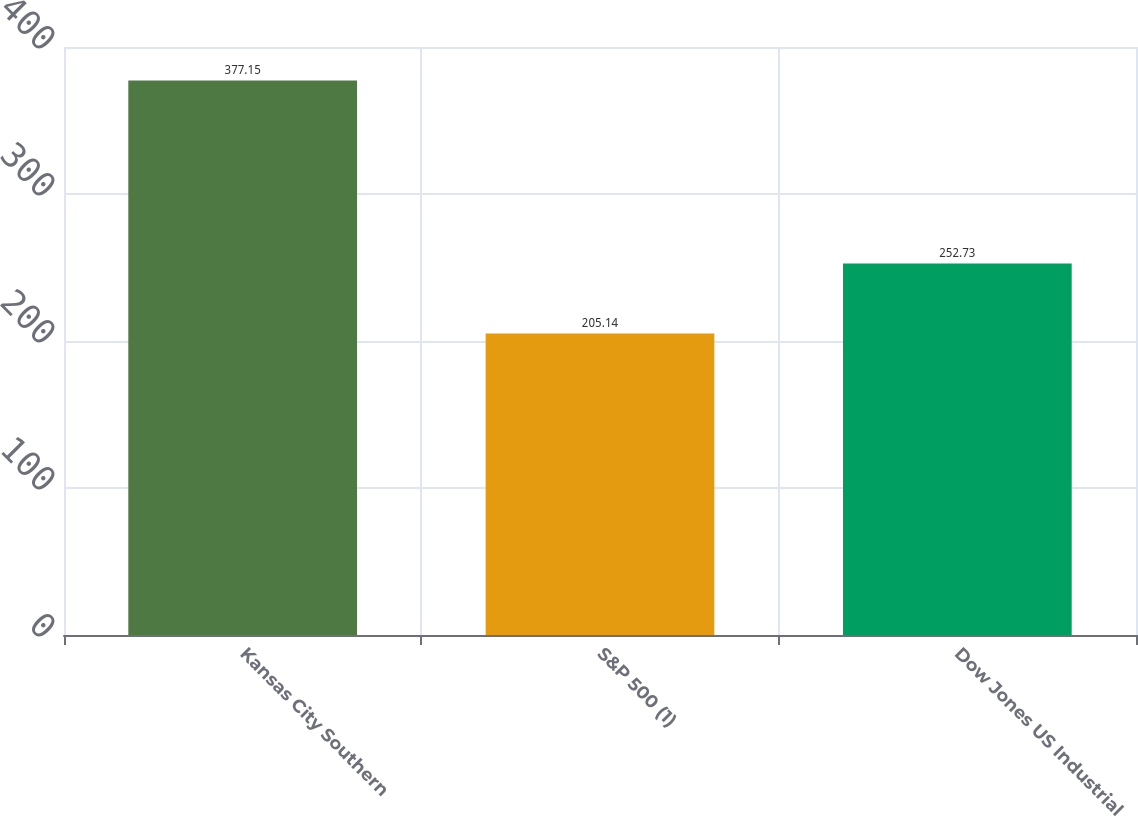Convert chart. <chart><loc_0><loc_0><loc_500><loc_500><bar_chart><fcel>Kansas City Southern<fcel>S&P 500 (1)<fcel>Dow Jones US Industrial<nl><fcel>377.15<fcel>205.14<fcel>252.73<nl></chart> 